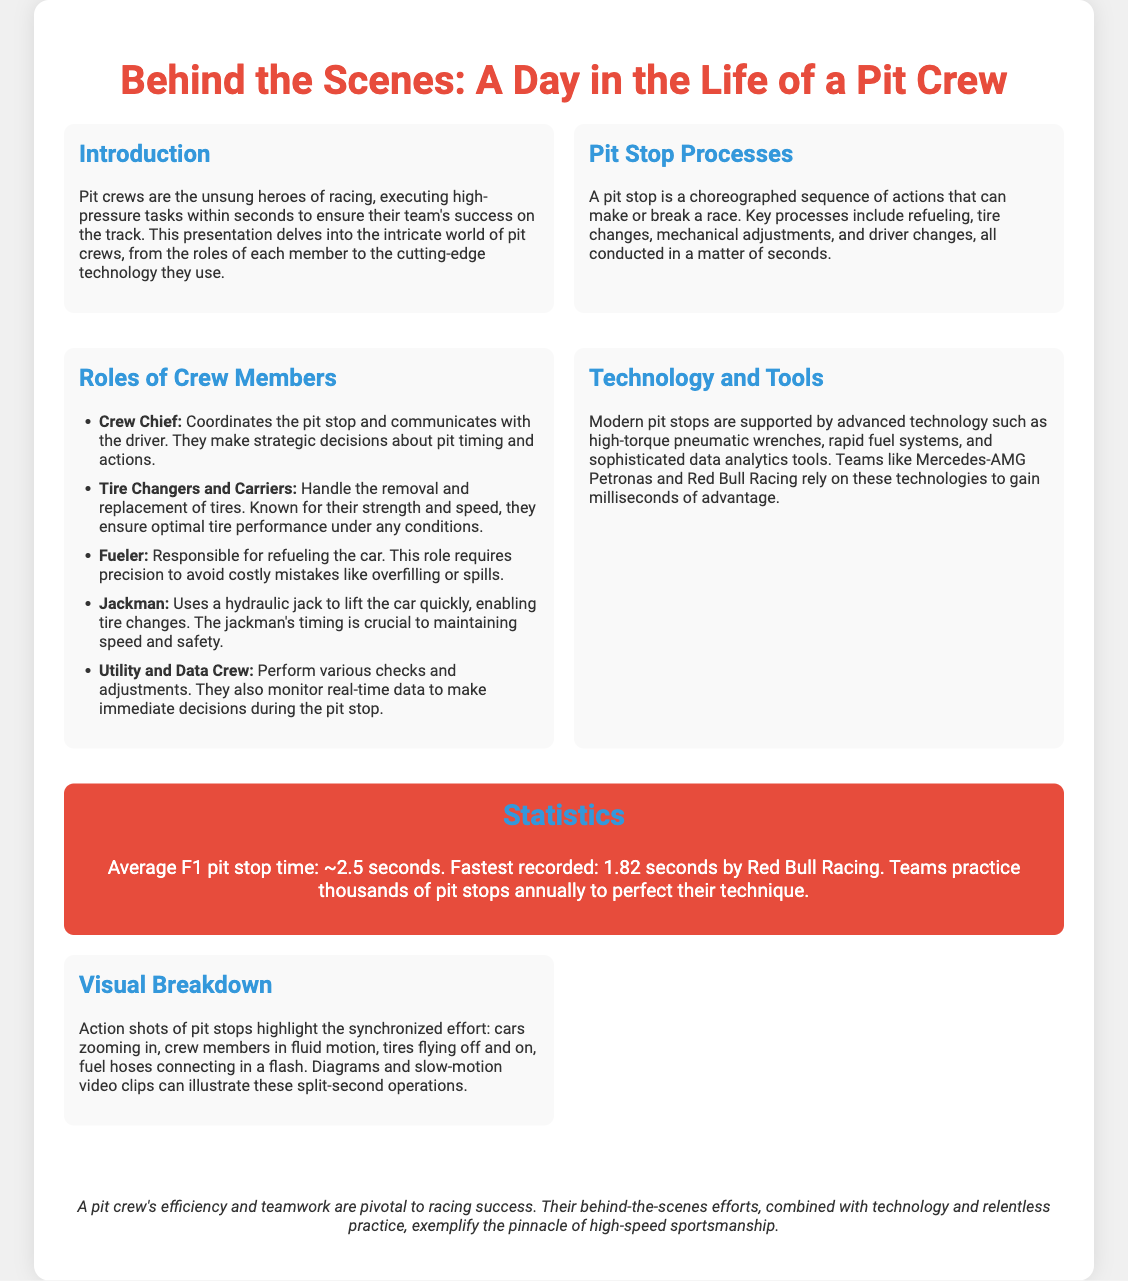What is the average F1 pit stop time? The document states that the average F1 pit stop time is approximately 2.5 seconds.
Answer: 2.5 seconds Who is responsible for refueling the car? The document lists the Fueler as the crew member responsible for refueling the car.
Answer: Fueler What technology is used to lift the car quickly? The document mentions the use of a hydraulic jack by the Jackman to lift the car quickly.
Answer: Hydraulic jack What is the fastest recorded pit stop time? According to the document, the fastest recorded pit stop time is 1.82 seconds by Red Bull Racing.
Answer: 1.82 seconds What roles do Tire Changers and Carriers perform? They handle the removal and replacement of tires.
Answer: Remove and replace tires Which teams rely on advanced technology for pit stops? The document specifically mentions Mercedes-AMG Petronas and Red Bull Racing as teams that rely on advanced technology.
Answer: Mercedes-AMG Petronas, Red Bull Racing How many pit stops do teams practice annually? The document states that teams practice thousands of pit stops annually to perfect their technique.
Answer: Thousands What is emphasized as crucial for the Jackman during a pit stop? The document emphasizes that the Jackman's timing is crucial to maintaining speed and safety.
Answer: Timing What is highlighted in the visual breakdown section of the presentation? The visual breakdown section highlights the synchronized effort of crew members during pit stops.
Answer: Synchronized effort 